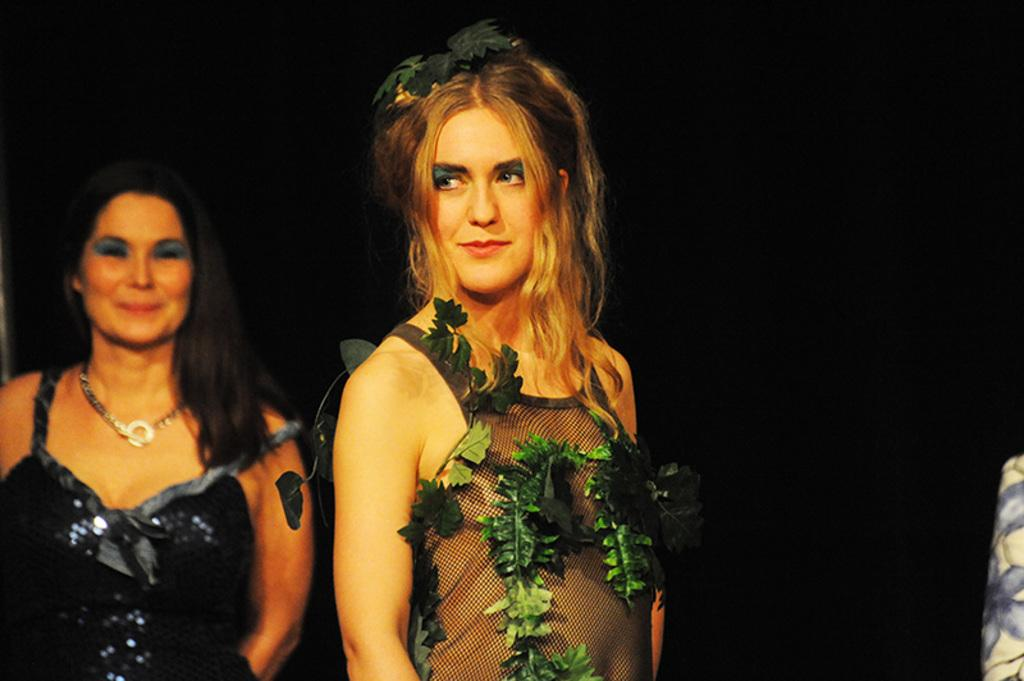How many people are in the image? There are two women standing in the image. What is the appearance of the cloth on one of the women? There is a cloth on the right side of one of the women. What can be observed about the lighting in the image? The background of the image is dark. How many ants can be seen crawling on the credit in the image? There are no ants or credit present in the image. 